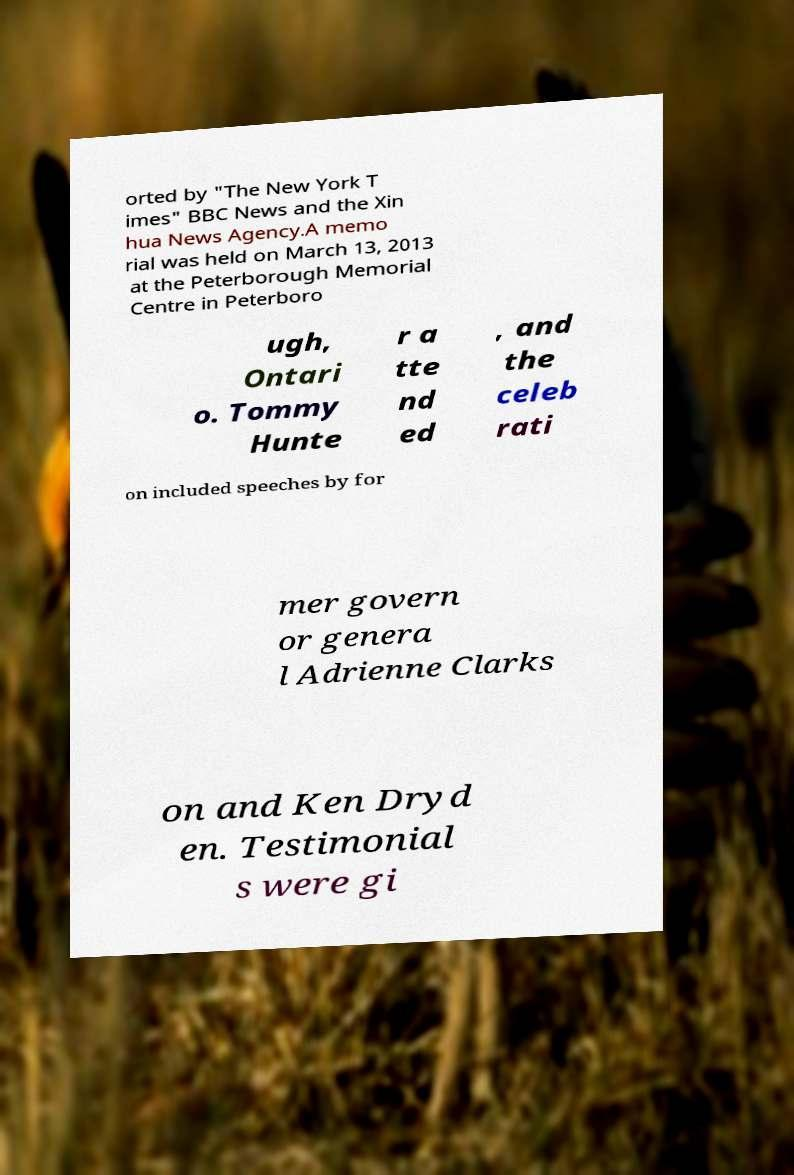Please identify and transcribe the text found in this image. orted by "The New York T imes" BBC News and the Xin hua News Agency.A memo rial was held on March 13, 2013 at the Peterborough Memorial Centre in Peterboro ugh, Ontari o. Tommy Hunte r a tte nd ed , and the celeb rati on included speeches by for mer govern or genera l Adrienne Clarks on and Ken Dryd en. Testimonial s were gi 